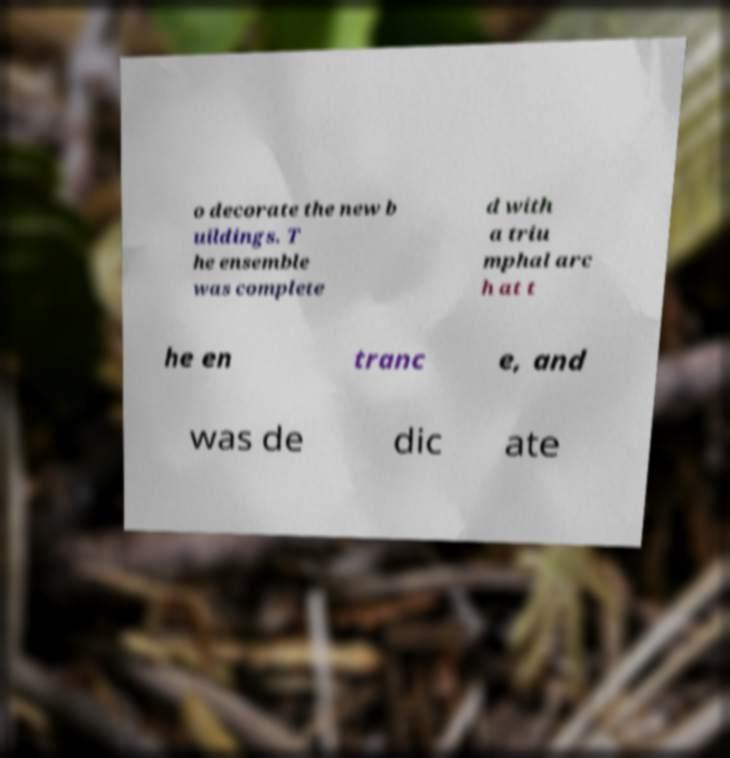Could you assist in decoding the text presented in this image and type it out clearly? o decorate the new b uildings. T he ensemble was complete d with a triu mphal arc h at t he en tranc e, and was de dic ate 